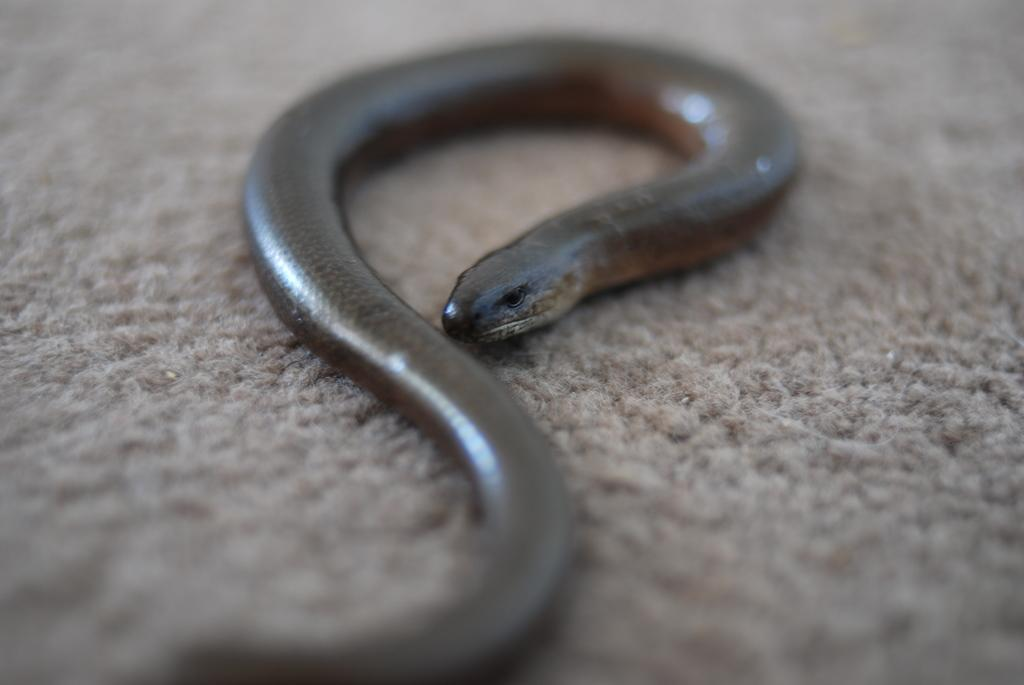What is the main subject in the center of the image? There is a snake in the center of the image. What is located at the bottom of the image? There is a carpet at the bottom of the image. What is the temper of the parcel in the image? There is no parcel present in the image, and therefore no temper can be assessed. 